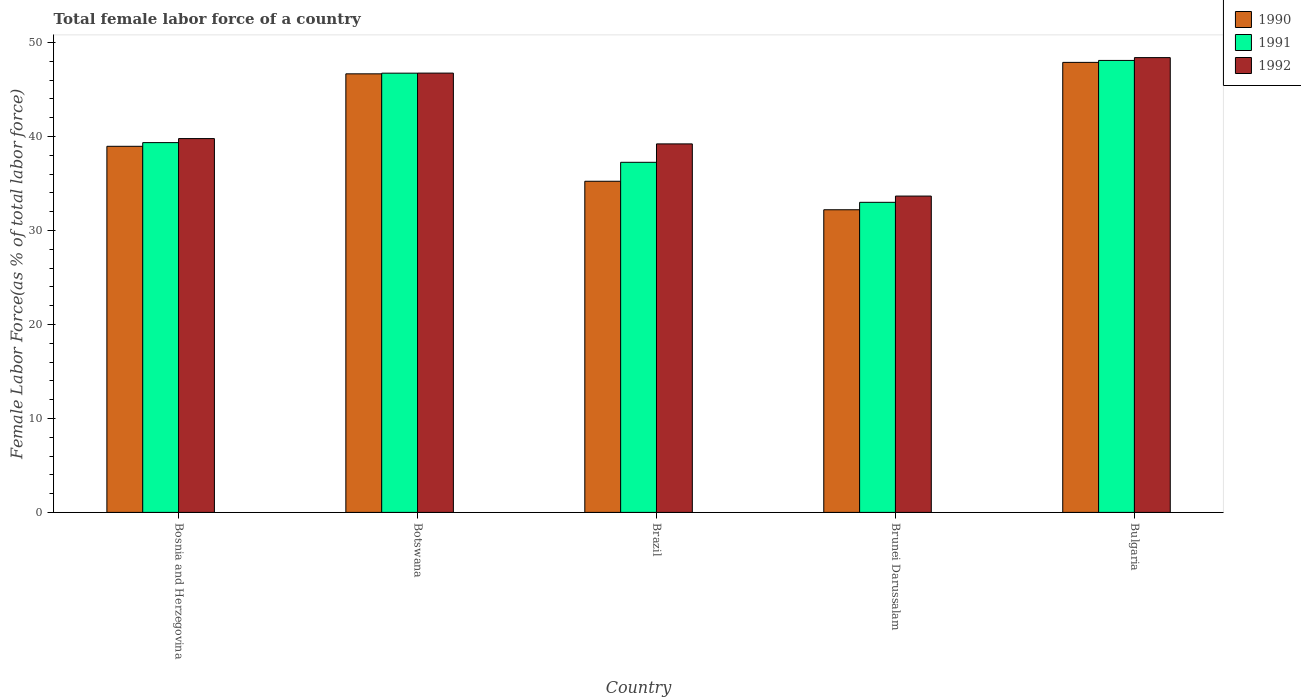How many different coloured bars are there?
Your answer should be very brief. 3. How many groups of bars are there?
Provide a short and direct response. 5. Are the number of bars per tick equal to the number of legend labels?
Give a very brief answer. Yes. What is the label of the 4th group of bars from the left?
Provide a succinct answer. Brunei Darussalam. What is the percentage of female labor force in 1992 in Brunei Darussalam?
Ensure brevity in your answer.  33.66. Across all countries, what is the maximum percentage of female labor force in 1991?
Your answer should be compact. 48.09. Across all countries, what is the minimum percentage of female labor force in 1992?
Offer a terse response. 33.66. In which country was the percentage of female labor force in 1991 maximum?
Ensure brevity in your answer.  Bulgaria. In which country was the percentage of female labor force in 1991 minimum?
Your answer should be very brief. Brunei Darussalam. What is the total percentage of female labor force in 1991 in the graph?
Your answer should be compact. 204.43. What is the difference between the percentage of female labor force in 1992 in Bosnia and Herzegovina and that in Bulgaria?
Ensure brevity in your answer.  -8.62. What is the difference between the percentage of female labor force in 1992 in Botswana and the percentage of female labor force in 1990 in Brunei Darussalam?
Provide a succinct answer. 14.54. What is the average percentage of female labor force in 1992 per country?
Your response must be concise. 41.56. What is the difference between the percentage of female labor force of/in 1990 and percentage of female labor force of/in 1992 in Bosnia and Herzegovina?
Your response must be concise. -0.82. What is the ratio of the percentage of female labor force in 1990 in Brunei Darussalam to that in Bulgaria?
Give a very brief answer. 0.67. Is the percentage of female labor force in 1992 in Brunei Darussalam less than that in Bulgaria?
Your answer should be compact. Yes. What is the difference between the highest and the second highest percentage of female labor force in 1992?
Offer a terse response. 1.65. What is the difference between the highest and the lowest percentage of female labor force in 1992?
Offer a very short reply. 14.73. In how many countries, is the percentage of female labor force in 1991 greater than the average percentage of female labor force in 1991 taken over all countries?
Provide a succinct answer. 2. Is it the case that in every country, the sum of the percentage of female labor force in 1991 and percentage of female labor force in 1990 is greater than the percentage of female labor force in 1992?
Offer a very short reply. Yes. How many countries are there in the graph?
Your answer should be compact. 5. Does the graph contain any zero values?
Keep it short and to the point. No. What is the title of the graph?
Your answer should be compact. Total female labor force of a country. Does "1983" appear as one of the legend labels in the graph?
Provide a short and direct response. No. What is the label or title of the Y-axis?
Your answer should be compact. Female Labor Force(as % of total labor force). What is the Female Labor Force(as % of total labor force) of 1990 in Bosnia and Herzegovina?
Your response must be concise. 38.96. What is the Female Labor Force(as % of total labor force) of 1991 in Bosnia and Herzegovina?
Offer a terse response. 39.35. What is the Female Labor Force(as % of total labor force) in 1992 in Bosnia and Herzegovina?
Keep it short and to the point. 39.78. What is the Female Labor Force(as % of total labor force) in 1990 in Botswana?
Provide a succinct answer. 46.67. What is the Female Labor Force(as % of total labor force) in 1991 in Botswana?
Ensure brevity in your answer.  46.74. What is the Female Labor Force(as % of total labor force) in 1992 in Botswana?
Give a very brief answer. 46.75. What is the Female Labor Force(as % of total labor force) in 1990 in Brazil?
Offer a terse response. 35.24. What is the Female Labor Force(as % of total labor force) of 1991 in Brazil?
Your answer should be compact. 37.25. What is the Female Labor Force(as % of total labor force) of 1992 in Brazil?
Your response must be concise. 39.21. What is the Female Labor Force(as % of total labor force) of 1990 in Brunei Darussalam?
Provide a succinct answer. 32.2. What is the Female Labor Force(as % of total labor force) in 1991 in Brunei Darussalam?
Provide a succinct answer. 33. What is the Female Labor Force(as % of total labor force) in 1992 in Brunei Darussalam?
Your response must be concise. 33.66. What is the Female Labor Force(as % of total labor force) in 1990 in Bulgaria?
Offer a very short reply. 47.88. What is the Female Labor Force(as % of total labor force) of 1991 in Bulgaria?
Give a very brief answer. 48.09. What is the Female Labor Force(as % of total labor force) of 1992 in Bulgaria?
Your answer should be compact. 48.39. Across all countries, what is the maximum Female Labor Force(as % of total labor force) of 1990?
Give a very brief answer. 47.88. Across all countries, what is the maximum Female Labor Force(as % of total labor force) of 1991?
Ensure brevity in your answer.  48.09. Across all countries, what is the maximum Female Labor Force(as % of total labor force) of 1992?
Your answer should be compact. 48.39. Across all countries, what is the minimum Female Labor Force(as % of total labor force) in 1990?
Offer a very short reply. 32.2. Across all countries, what is the minimum Female Labor Force(as % of total labor force) in 1991?
Your answer should be very brief. 33. Across all countries, what is the minimum Female Labor Force(as % of total labor force) of 1992?
Offer a terse response. 33.66. What is the total Female Labor Force(as % of total labor force) in 1990 in the graph?
Keep it short and to the point. 200.95. What is the total Female Labor Force(as % of total labor force) in 1991 in the graph?
Your answer should be very brief. 204.43. What is the total Female Labor Force(as % of total labor force) in 1992 in the graph?
Offer a very short reply. 207.79. What is the difference between the Female Labor Force(as % of total labor force) of 1990 in Bosnia and Herzegovina and that in Botswana?
Keep it short and to the point. -7.71. What is the difference between the Female Labor Force(as % of total labor force) in 1991 in Bosnia and Herzegovina and that in Botswana?
Offer a terse response. -7.39. What is the difference between the Female Labor Force(as % of total labor force) of 1992 in Bosnia and Herzegovina and that in Botswana?
Ensure brevity in your answer.  -6.97. What is the difference between the Female Labor Force(as % of total labor force) in 1990 in Bosnia and Herzegovina and that in Brazil?
Your answer should be compact. 3.72. What is the difference between the Female Labor Force(as % of total labor force) in 1991 in Bosnia and Herzegovina and that in Brazil?
Offer a terse response. 2.1. What is the difference between the Female Labor Force(as % of total labor force) in 1992 in Bosnia and Herzegovina and that in Brazil?
Offer a terse response. 0.57. What is the difference between the Female Labor Force(as % of total labor force) of 1990 in Bosnia and Herzegovina and that in Brunei Darussalam?
Provide a short and direct response. 6.75. What is the difference between the Female Labor Force(as % of total labor force) of 1991 in Bosnia and Herzegovina and that in Brunei Darussalam?
Provide a succinct answer. 6.35. What is the difference between the Female Labor Force(as % of total labor force) of 1992 in Bosnia and Herzegovina and that in Brunei Darussalam?
Your answer should be compact. 6.12. What is the difference between the Female Labor Force(as % of total labor force) of 1990 in Bosnia and Herzegovina and that in Bulgaria?
Provide a succinct answer. -8.93. What is the difference between the Female Labor Force(as % of total labor force) in 1991 in Bosnia and Herzegovina and that in Bulgaria?
Your answer should be compact. -8.74. What is the difference between the Female Labor Force(as % of total labor force) in 1992 in Bosnia and Herzegovina and that in Bulgaria?
Ensure brevity in your answer.  -8.62. What is the difference between the Female Labor Force(as % of total labor force) in 1990 in Botswana and that in Brazil?
Ensure brevity in your answer.  11.43. What is the difference between the Female Labor Force(as % of total labor force) of 1991 in Botswana and that in Brazil?
Offer a very short reply. 9.48. What is the difference between the Female Labor Force(as % of total labor force) in 1992 in Botswana and that in Brazil?
Your answer should be compact. 7.53. What is the difference between the Female Labor Force(as % of total labor force) of 1990 in Botswana and that in Brunei Darussalam?
Provide a succinct answer. 14.46. What is the difference between the Female Labor Force(as % of total labor force) of 1991 in Botswana and that in Brunei Darussalam?
Ensure brevity in your answer.  13.74. What is the difference between the Female Labor Force(as % of total labor force) of 1992 in Botswana and that in Brunei Darussalam?
Offer a very short reply. 13.09. What is the difference between the Female Labor Force(as % of total labor force) of 1990 in Botswana and that in Bulgaria?
Give a very brief answer. -1.22. What is the difference between the Female Labor Force(as % of total labor force) in 1991 in Botswana and that in Bulgaria?
Your response must be concise. -1.36. What is the difference between the Female Labor Force(as % of total labor force) in 1992 in Botswana and that in Bulgaria?
Keep it short and to the point. -1.65. What is the difference between the Female Labor Force(as % of total labor force) in 1990 in Brazil and that in Brunei Darussalam?
Your answer should be very brief. 3.03. What is the difference between the Female Labor Force(as % of total labor force) in 1991 in Brazil and that in Brunei Darussalam?
Your answer should be compact. 4.26. What is the difference between the Female Labor Force(as % of total labor force) of 1992 in Brazil and that in Brunei Darussalam?
Ensure brevity in your answer.  5.55. What is the difference between the Female Labor Force(as % of total labor force) in 1990 in Brazil and that in Bulgaria?
Ensure brevity in your answer.  -12.65. What is the difference between the Female Labor Force(as % of total labor force) in 1991 in Brazil and that in Bulgaria?
Make the answer very short. -10.84. What is the difference between the Female Labor Force(as % of total labor force) in 1992 in Brazil and that in Bulgaria?
Offer a terse response. -9.18. What is the difference between the Female Labor Force(as % of total labor force) in 1990 in Brunei Darussalam and that in Bulgaria?
Make the answer very short. -15.68. What is the difference between the Female Labor Force(as % of total labor force) in 1991 in Brunei Darussalam and that in Bulgaria?
Give a very brief answer. -15.1. What is the difference between the Female Labor Force(as % of total labor force) of 1992 in Brunei Darussalam and that in Bulgaria?
Make the answer very short. -14.73. What is the difference between the Female Labor Force(as % of total labor force) in 1990 in Bosnia and Herzegovina and the Female Labor Force(as % of total labor force) in 1991 in Botswana?
Provide a short and direct response. -7.78. What is the difference between the Female Labor Force(as % of total labor force) in 1990 in Bosnia and Herzegovina and the Female Labor Force(as % of total labor force) in 1992 in Botswana?
Provide a succinct answer. -7.79. What is the difference between the Female Labor Force(as % of total labor force) in 1991 in Bosnia and Herzegovina and the Female Labor Force(as % of total labor force) in 1992 in Botswana?
Provide a short and direct response. -7.4. What is the difference between the Female Labor Force(as % of total labor force) in 1990 in Bosnia and Herzegovina and the Female Labor Force(as % of total labor force) in 1991 in Brazil?
Provide a short and direct response. 1.7. What is the difference between the Female Labor Force(as % of total labor force) in 1990 in Bosnia and Herzegovina and the Female Labor Force(as % of total labor force) in 1992 in Brazil?
Make the answer very short. -0.26. What is the difference between the Female Labor Force(as % of total labor force) in 1991 in Bosnia and Herzegovina and the Female Labor Force(as % of total labor force) in 1992 in Brazil?
Keep it short and to the point. 0.14. What is the difference between the Female Labor Force(as % of total labor force) in 1990 in Bosnia and Herzegovina and the Female Labor Force(as % of total labor force) in 1991 in Brunei Darussalam?
Ensure brevity in your answer.  5.96. What is the difference between the Female Labor Force(as % of total labor force) in 1990 in Bosnia and Herzegovina and the Female Labor Force(as % of total labor force) in 1992 in Brunei Darussalam?
Your answer should be very brief. 5.3. What is the difference between the Female Labor Force(as % of total labor force) in 1991 in Bosnia and Herzegovina and the Female Labor Force(as % of total labor force) in 1992 in Brunei Darussalam?
Keep it short and to the point. 5.69. What is the difference between the Female Labor Force(as % of total labor force) of 1990 in Bosnia and Herzegovina and the Female Labor Force(as % of total labor force) of 1991 in Bulgaria?
Give a very brief answer. -9.14. What is the difference between the Female Labor Force(as % of total labor force) of 1990 in Bosnia and Herzegovina and the Female Labor Force(as % of total labor force) of 1992 in Bulgaria?
Provide a short and direct response. -9.44. What is the difference between the Female Labor Force(as % of total labor force) in 1991 in Bosnia and Herzegovina and the Female Labor Force(as % of total labor force) in 1992 in Bulgaria?
Offer a very short reply. -9.04. What is the difference between the Female Labor Force(as % of total labor force) of 1990 in Botswana and the Female Labor Force(as % of total labor force) of 1991 in Brazil?
Give a very brief answer. 9.41. What is the difference between the Female Labor Force(as % of total labor force) of 1990 in Botswana and the Female Labor Force(as % of total labor force) of 1992 in Brazil?
Provide a short and direct response. 7.45. What is the difference between the Female Labor Force(as % of total labor force) in 1991 in Botswana and the Female Labor Force(as % of total labor force) in 1992 in Brazil?
Keep it short and to the point. 7.53. What is the difference between the Female Labor Force(as % of total labor force) of 1990 in Botswana and the Female Labor Force(as % of total labor force) of 1991 in Brunei Darussalam?
Provide a succinct answer. 13.67. What is the difference between the Female Labor Force(as % of total labor force) of 1990 in Botswana and the Female Labor Force(as % of total labor force) of 1992 in Brunei Darussalam?
Ensure brevity in your answer.  13.01. What is the difference between the Female Labor Force(as % of total labor force) in 1991 in Botswana and the Female Labor Force(as % of total labor force) in 1992 in Brunei Darussalam?
Provide a short and direct response. 13.08. What is the difference between the Female Labor Force(as % of total labor force) of 1990 in Botswana and the Female Labor Force(as % of total labor force) of 1991 in Bulgaria?
Keep it short and to the point. -1.43. What is the difference between the Female Labor Force(as % of total labor force) in 1990 in Botswana and the Female Labor Force(as % of total labor force) in 1992 in Bulgaria?
Ensure brevity in your answer.  -1.73. What is the difference between the Female Labor Force(as % of total labor force) in 1991 in Botswana and the Female Labor Force(as % of total labor force) in 1992 in Bulgaria?
Your answer should be compact. -1.66. What is the difference between the Female Labor Force(as % of total labor force) of 1990 in Brazil and the Female Labor Force(as % of total labor force) of 1991 in Brunei Darussalam?
Offer a terse response. 2.24. What is the difference between the Female Labor Force(as % of total labor force) in 1990 in Brazil and the Female Labor Force(as % of total labor force) in 1992 in Brunei Darussalam?
Offer a terse response. 1.58. What is the difference between the Female Labor Force(as % of total labor force) of 1991 in Brazil and the Female Labor Force(as % of total labor force) of 1992 in Brunei Darussalam?
Keep it short and to the point. 3.59. What is the difference between the Female Labor Force(as % of total labor force) in 1990 in Brazil and the Female Labor Force(as % of total labor force) in 1991 in Bulgaria?
Keep it short and to the point. -12.86. What is the difference between the Female Labor Force(as % of total labor force) of 1990 in Brazil and the Female Labor Force(as % of total labor force) of 1992 in Bulgaria?
Offer a very short reply. -13.16. What is the difference between the Female Labor Force(as % of total labor force) in 1991 in Brazil and the Female Labor Force(as % of total labor force) in 1992 in Bulgaria?
Your answer should be very brief. -11.14. What is the difference between the Female Labor Force(as % of total labor force) in 1990 in Brunei Darussalam and the Female Labor Force(as % of total labor force) in 1991 in Bulgaria?
Make the answer very short. -15.89. What is the difference between the Female Labor Force(as % of total labor force) in 1990 in Brunei Darussalam and the Female Labor Force(as % of total labor force) in 1992 in Bulgaria?
Your response must be concise. -16.19. What is the difference between the Female Labor Force(as % of total labor force) of 1991 in Brunei Darussalam and the Female Labor Force(as % of total labor force) of 1992 in Bulgaria?
Provide a short and direct response. -15.4. What is the average Female Labor Force(as % of total labor force) in 1990 per country?
Ensure brevity in your answer.  40.19. What is the average Female Labor Force(as % of total labor force) in 1991 per country?
Provide a succinct answer. 40.89. What is the average Female Labor Force(as % of total labor force) in 1992 per country?
Your answer should be compact. 41.56. What is the difference between the Female Labor Force(as % of total labor force) in 1990 and Female Labor Force(as % of total labor force) in 1991 in Bosnia and Herzegovina?
Give a very brief answer. -0.39. What is the difference between the Female Labor Force(as % of total labor force) in 1990 and Female Labor Force(as % of total labor force) in 1992 in Bosnia and Herzegovina?
Your answer should be compact. -0.82. What is the difference between the Female Labor Force(as % of total labor force) in 1991 and Female Labor Force(as % of total labor force) in 1992 in Bosnia and Herzegovina?
Your answer should be compact. -0.43. What is the difference between the Female Labor Force(as % of total labor force) of 1990 and Female Labor Force(as % of total labor force) of 1991 in Botswana?
Your answer should be very brief. -0.07. What is the difference between the Female Labor Force(as % of total labor force) of 1990 and Female Labor Force(as % of total labor force) of 1992 in Botswana?
Your answer should be very brief. -0.08. What is the difference between the Female Labor Force(as % of total labor force) in 1991 and Female Labor Force(as % of total labor force) in 1992 in Botswana?
Your answer should be very brief. -0.01. What is the difference between the Female Labor Force(as % of total labor force) in 1990 and Female Labor Force(as % of total labor force) in 1991 in Brazil?
Offer a very short reply. -2.02. What is the difference between the Female Labor Force(as % of total labor force) of 1990 and Female Labor Force(as % of total labor force) of 1992 in Brazil?
Your answer should be compact. -3.97. What is the difference between the Female Labor Force(as % of total labor force) of 1991 and Female Labor Force(as % of total labor force) of 1992 in Brazil?
Offer a terse response. -1.96. What is the difference between the Female Labor Force(as % of total labor force) of 1990 and Female Labor Force(as % of total labor force) of 1991 in Brunei Darussalam?
Offer a very short reply. -0.79. What is the difference between the Female Labor Force(as % of total labor force) in 1990 and Female Labor Force(as % of total labor force) in 1992 in Brunei Darussalam?
Keep it short and to the point. -1.46. What is the difference between the Female Labor Force(as % of total labor force) of 1991 and Female Labor Force(as % of total labor force) of 1992 in Brunei Darussalam?
Make the answer very short. -0.66. What is the difference between the Female Labor Force(as % of total labor force) in 1990 and Female Labor Force(as % of total labor force) in 1991 in Bulgaria?
Provide a succinct answer. -0.21. What is the difference between the Female Labor Force(as % of total labor force) in 1990 and Female Labor Force(as % of total labor force) in 1992 in Bulgaria?
Keep it short and to the point. -0.51. What is the difference between the Female Labor Force(as % of total labor force) in 1991 and Female Labor Force(as % of total labor force) in 1992 in Bulgaria?
Offer a terse response. -0.3. What is the ratio of the Female Labor Force(as % of total labor force) in 1990 in Bosnia and Herzegovina to that in Botswana?
Give a very brief answer. 0.83. What is the ratio of the Female Labor Force(as % of total labor force) of 1991 in Bosnia and Herzegovina to that in Botswana?
Provide a short and direct response. 0.84. What is the ratio of the Female Labor Force(as % of total labor force) in 1992 in Bosnia and Herzegovina to that in Botswana?
Your response must be concise. 0.85. What is the ratio of the Female Labor Force(as % of total labor force) in 1990 in Bosnia and Herzegovina to that in Brazil?
Give a very brief answer. 1.11. What is the ratio of the Female Labor Force(as % of total labor force) in 1991 in Bosnia and Herzegovina to that in Brazil?
Your response must be concise. 1.06. What is the ratio of the Female Labor Force(as % of total labor force) in 1992 in Bosnia and Herzegovina to that in Brazil?
Provide a short and direct response. 1.01. What is the ratio of the Female Labor Force(as % of total labor force) of 1990 in Bosnia and Herzegovina to that in Brunei Darussalam?
Ensure brevity in your answer.  1.21. What is the ratio of the Female Labor Force(as % of total labor force) in 1991 in Bosnia and Herzegovina to that in Brunei Darussalam?
Give a very brief answer. 1.19. What is the ratio of the Female Labor Force(as % of total labor force) of 1992 in Bosnia and Herzegovina to that in Brunei Darussalam?
Keep it short and to the point. 1.18. What is the ratio of the Female Labor Force(as % of total labor force) in 1990 in Bosnia and Herzegovina to that in Bulgaria?
Ensure brevity in your answer.  0.81. What is the ratio of the Female Labor Force(as % of total labor force) in 1991 in Bosnia and Herzegovina to that in Bulgaria?
Offer a terse response. 0.82. What is the ratio of the Female Labor Force(as % of total labor force) of 1992 in Bosnia and Herzegovina to that in Bulgaria?
Your answer should be very brief. 0.82. What is the ratio of the Female Labor Force(as % of total labor force) of 1990 in Botswana to that in Brazil?
Keep it short and to the point. 1.32. What is the ratio of the Female Labor Force(as % of total labor force) of 1991 in Botswana to that in Brazil?
Give a very brief answer. 1.25. What is the ratio of the Female Labor Force(as % of total labor force) of 1992 in Botswana to that in Brazil?
Provide a succinct answer. 1.19. What is the ratio of the Female Labor Force(as % of total labor force) of 1990 in Botswana to that in Brunei Darussalam?
Keep it short and to the point. 1.45. What is the ratio of the Female Labor Force(as % of total labor force) in 1991 in Botswana to that in Brunei Darussalam?
Your response must be concise. 1.42. What is the ratio of the Female Labor Force(as % of total labor force) in 1992 in Botswana to that in Brunei Darussalam?
Keep it short and to the point. 1.39. What is the ratio of the Female Labor Force(as % of total labor force) of 1990 in Botswana to that in Bulgaria?
Provide a short and direct response. 0.97. What is the ratio of the Female Labor Force(as % of total labor force) in 1991 in Botswana to that in Bulgaria?
Provide a succinct answer. 0.97. What is the ratio of the Female Labor Force(as % of total labor force) in 1992 in Botswana to that in Bulgaria?
Your answer should be compact. 0.97. What is the ratio of the Female Labor Force(as % of total labor force) of 1990 in Brazil to that in Brunei Darussalam?
Offer a terse response. 1.09. What is the ratio of the Female Labor Force(as % of total labor force) of 1991 in Brazil to that in Brunei Darussalam?
Your response must be concise. 1.13. What is the ratio of the Female Labor Force(as % of total labor force) in 1992 in Brazil to that in Brunei Darussalam?
Your response must be concise. 1.16. What is the ratio of the Female Labor Force(as % of total labor force) of 1990 in Brazil to that in Bulgaria?
Ensure brevity in your answer.  0.74. What is the ratio of the Female Labor Force(as % of total labor force) of 1991 in Brazil to that in Bulgaria?
Provide a short and direct response. 0.77. What is the ratio of the Female Labor Force(as % of total labor force) of 1992 in Brazil to that in Bulgaria?
Offer a very short reply. 0.81. What is the ratio of the Female Labor Force(as % of total labor force) in 1990 in Brunei Darussalam to that in Bulgaria?
Offer a very short reply. 0.67. What is the ratio of the Female Labor Force(as % of total labor force) of 1991 in Brunei Darussalam to that in Bulgaria?
Provide a succinct answer. 0.69. What is the ratio of the Female Labor Force(as % of total labor force) of 1992 in Brunei Darussalam to that in Bulgaria?
Keep it short and to the point. 0.7. What is the difference between the highest and the second highest Female Labor Force(as % of total labor force) in 1990?
Offer a very short reply. 1.22. What is the difference between the highest and the second highest Female Labor Force(as % of total labor force) of 1991?
Your answer should be compact. 1.36. What is the difference between the highest and the second highest Female Labor Force(as % of total labor force) of 1992?
Keep it short and to the point. 1.65. What is the difference between the highest and the lowest Female Labor Force(as % of total labor force) of 1990?
Ensure brevity in your answer.  15.68. What is the difference between the highest and the lowest Female Labor Force(as % of total labor force) of 1991?
Give a very brief answer. 15.1. What is the difference between the highest and the lowest Female Labor Force(as % of total labor force) of 1992?
Make the answer very short. 14.73. 